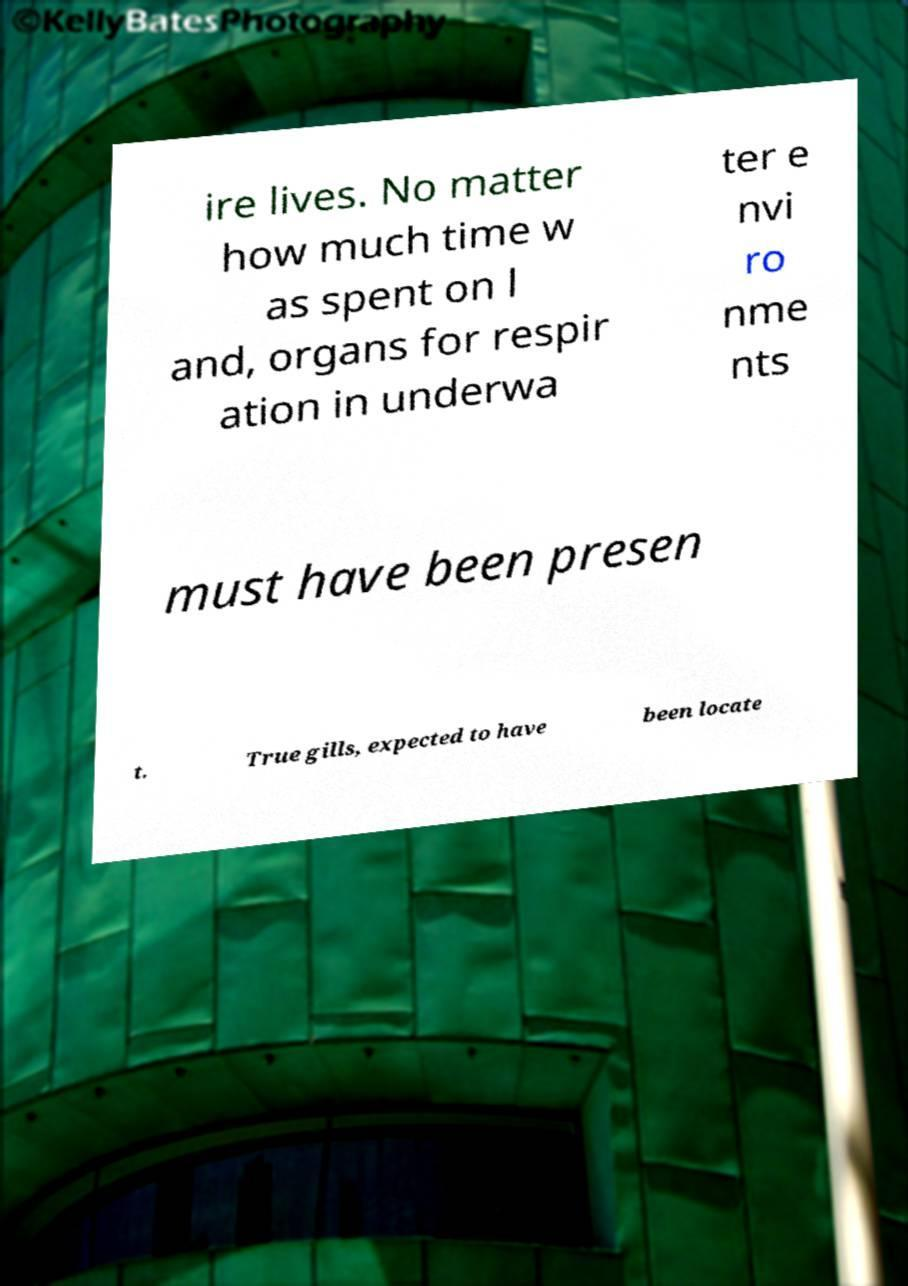Please read and relay the text visible in this image. What does it say? ire lives. No matter how much time w as spent on l and, organs for respir ation in underwa ter e nvi ro nme nts must have been presen t. True gills, expected to have been locate 